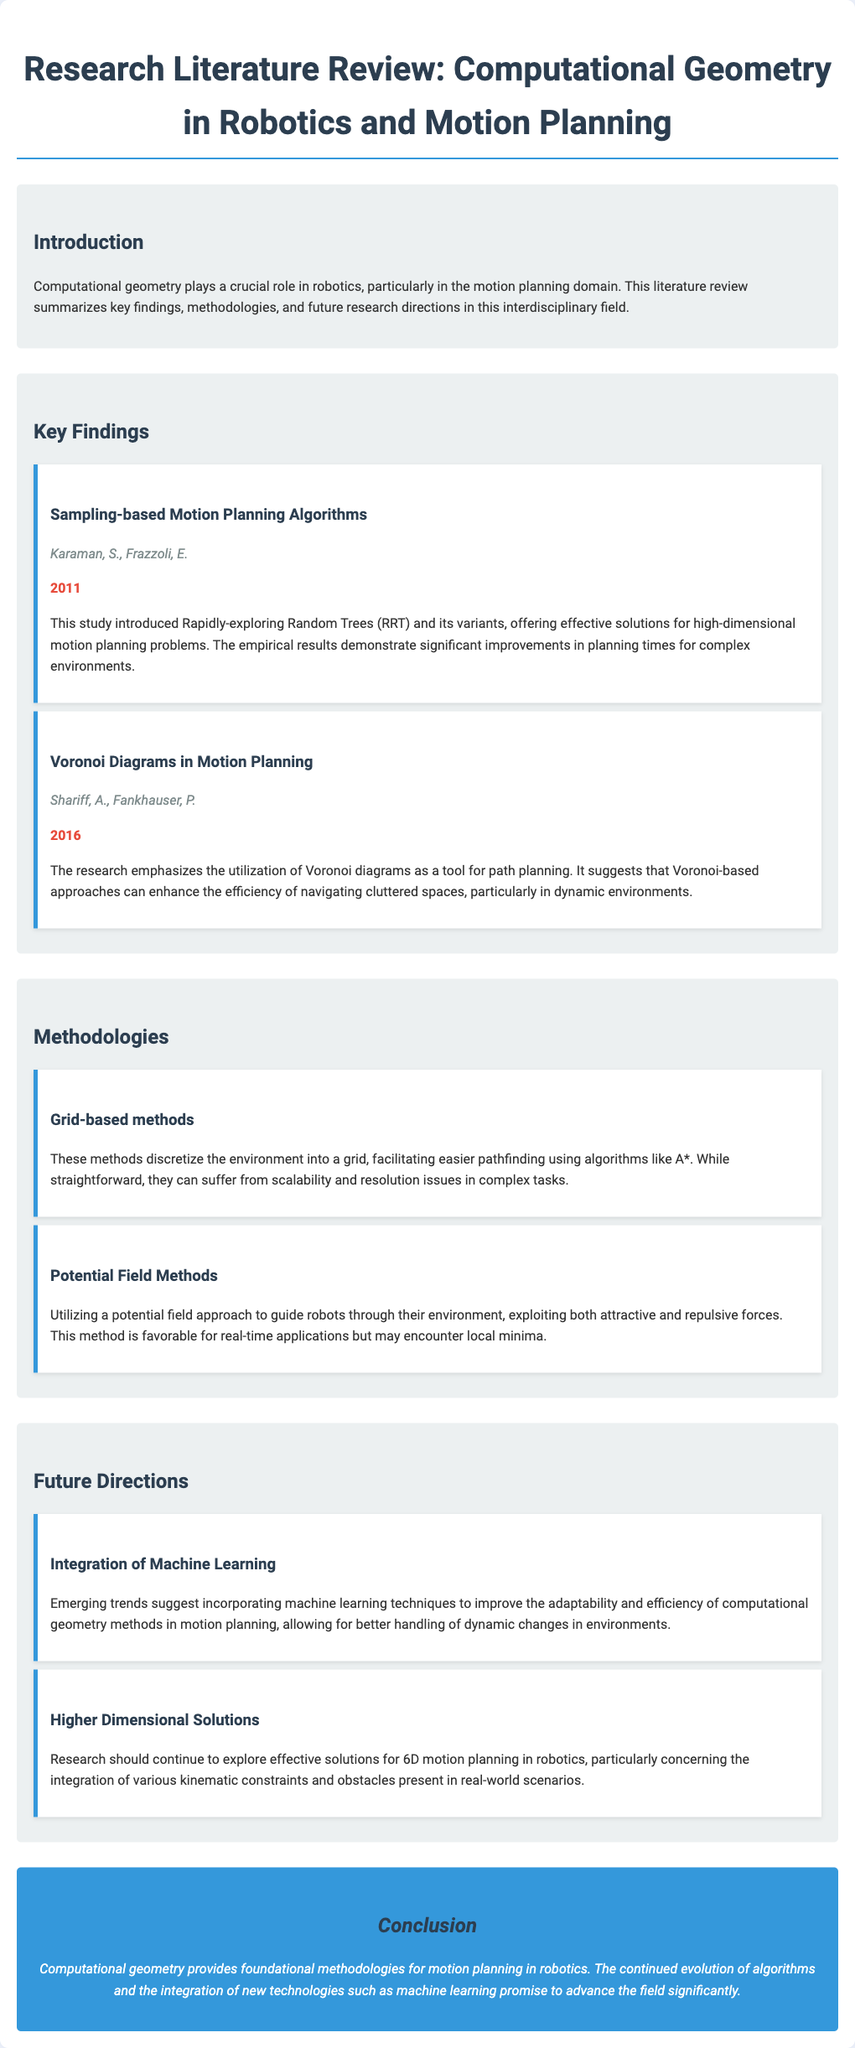What year was the study by Karaman and Frazzoli published? The year of publication for the study mentioned is indicated directly in the document under the key findings section for Karaman and Frazzoli.
Answer: 2011 What method did Shariff and Fankhauser focus on for path planning? The method highlighted by Shariff and Fankhauser emphasized the use of Voronoi diagrams as an effective tool for path planning.
Answer: Voronoi diagrams What are the two types of methods discussed under Methodologies? The document classifies methodologies under two categories: Grid-based methods and Potential Field Methods.
Answer: Grid-based methods and Potential Field Methods What is a potential issue with grid-based methods? The methods are described to have potential downsides regarding scalability and resolution in complex tasks.
Answer: Scalability and resolution issues Which future direction suggests using machine learning techniques? The future direction that mentions integration with machine learning is explicitly noted in the section regarding future research directions.
Answer: Integration of Machine Learning What role does computational geometry play in robotics? The introduction specifies that computational geometry plays a crucial role in the realm of robotics, particularly in motion planning.
Answer: Crucial role in motion planning How do potential field methods guide robots? The document mentions that potential field methods guide robots through utilizing attractive and repulsive forces in their environment.
Answer: Attractive and repulsive forces What is the primary focus of the conclusion? The conclusion summarizes the impact of computational geometry on motion planning and mentions the integration of new technologies as a promising advancement.
Answer: Foundational methodologies for motion planning in robotics 